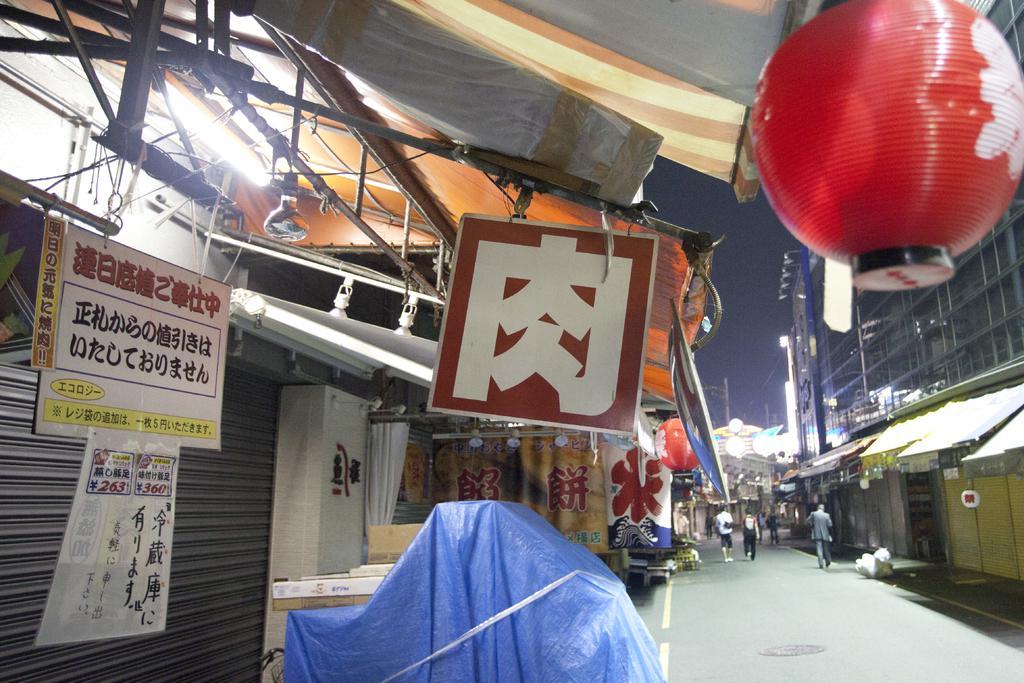Describe this image in one or two sentences. In this image there is the sky, there is a building truncated towards the right of the image, there is road, there are persons walking on the road, there is shop towards the left of the image, there is a light, there are boards, there are objects on the floor, there is an object changes towards the right of the image. 